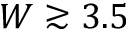<formula> <loc_0><loc_0><loc_500><loc_500>W \gtrsim 3 . 5</formula> 